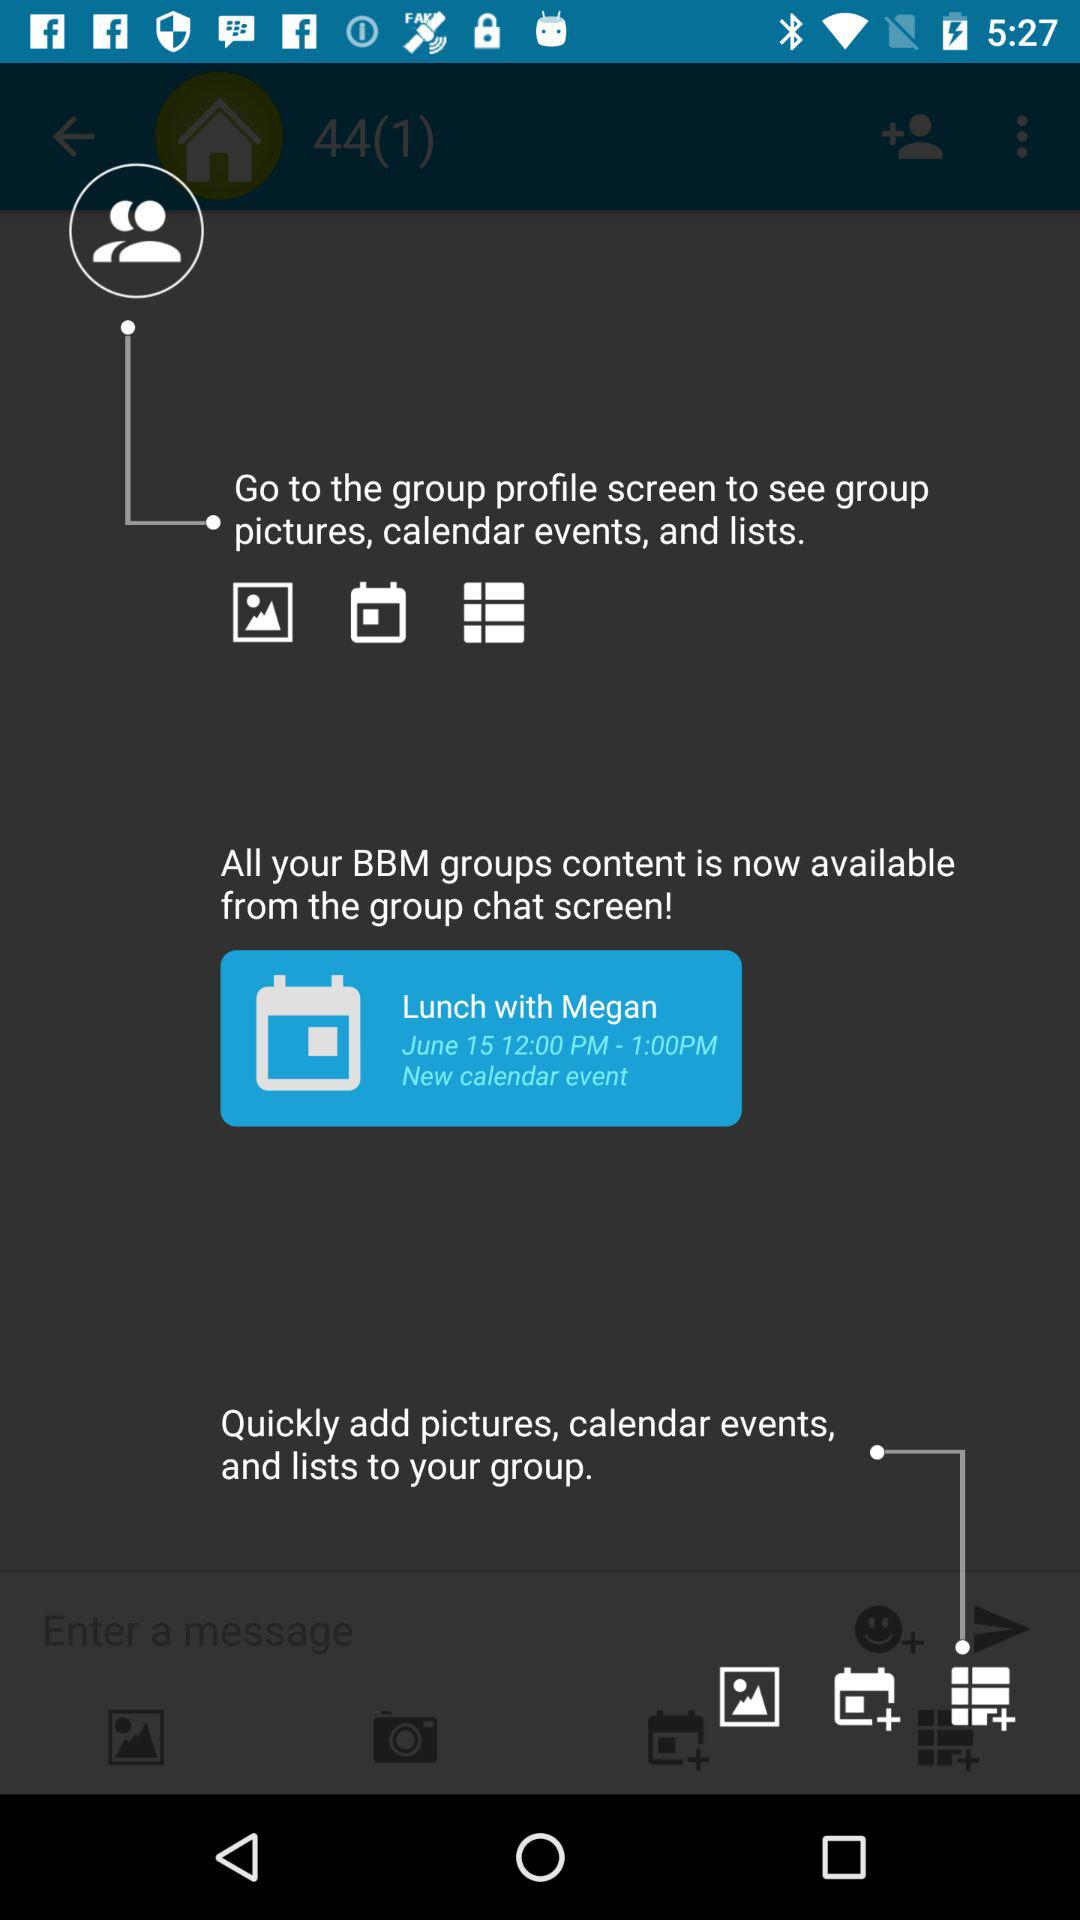What is the new calendar event? The new calendar event is "Lunch with Megan". 